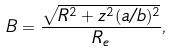Convert formula to latex. <formula><loc_0><loc_0><loc_500><loc_500>B = \frac { \sqrt { R ^ { 2 } + z ^ { 2 } ( a / b ) ^ { 2 } } } { R _ { e } } ,</formula> 